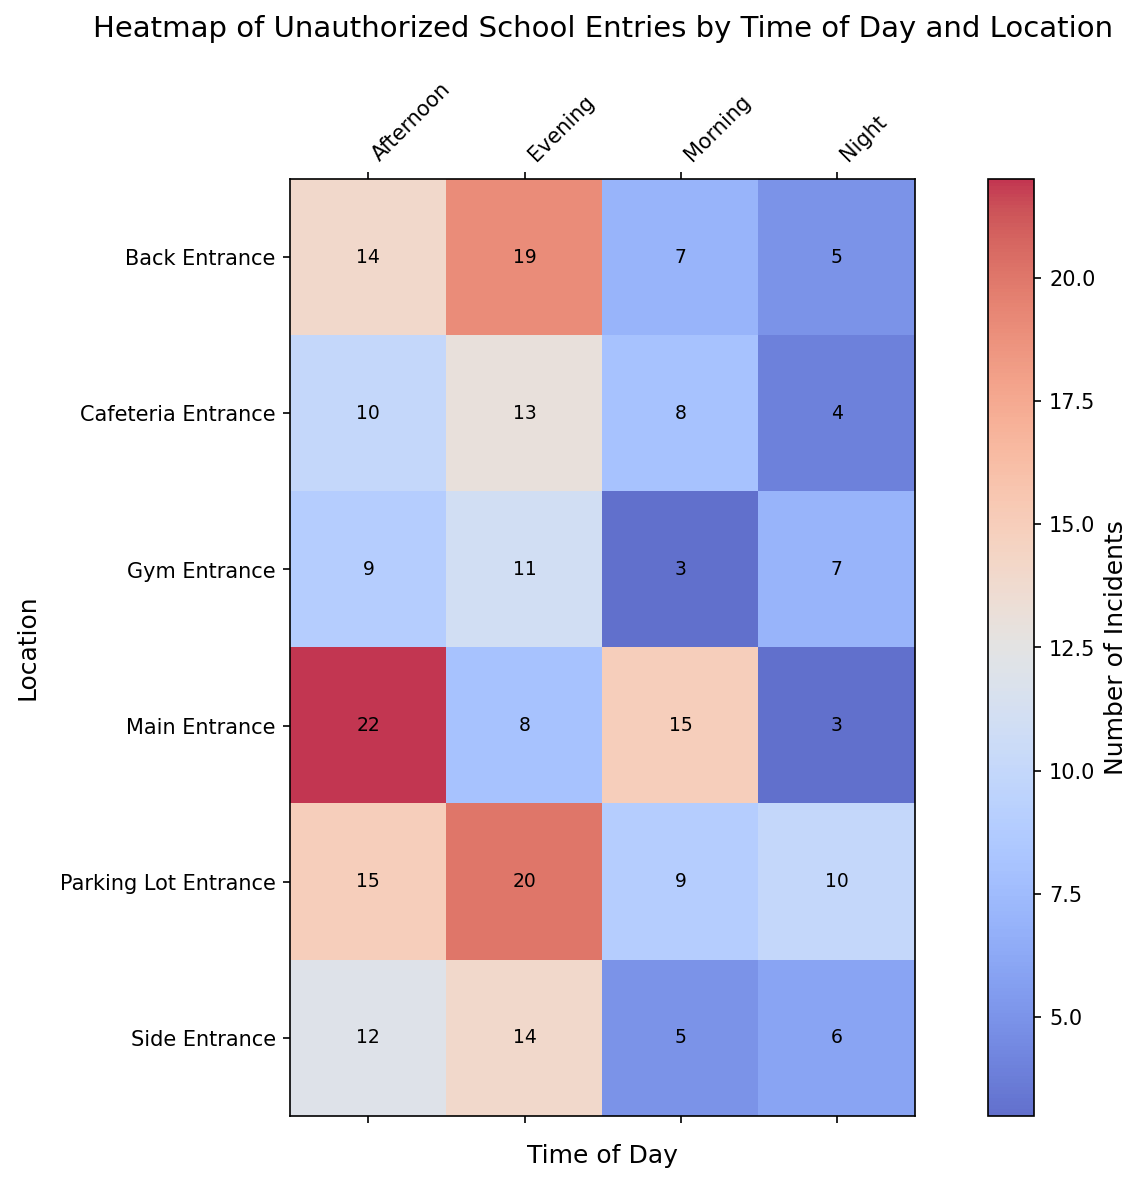Which location has the most incidents of unauthorized school entries during the evening? Look at the "Evening" column and identify the location with the highest number. The Parking Lot Entrance has 20 incidents, which is the highest.
Answer: Parking Lot Entrance Which time of day appears to have the fewest incidents overall across all locations? Sum the incidents for each time of day: Morning (47), Afternoon (82), Evening (85), Night (35). Night has the fewest.
Answer: Night How many more incidents occurred at the Main Entrance in the afternoon compared to the evening? Look at the Main Entrance row for Afternoon (22) and Evening (8). Subtract Evening from Afternoon: 22 - 8 = 14
Answer: 14 Which entrance has the highest incidents during the night, and how many incidents are there? Look at the "Night" column and find the highest number, which is at the Parking Lot Entrance with 10 incidents.
Answer: Parking Lot Entrance, 10 What is the average number of incidents at the Back Entrance across all times of the day? Calculate the average: (7 + 14 + 19 + 5) / 4 = 45 / 4 = 11.25
Answer: 11.25 How does the total number of incidents at the Side Entrance compare to the Gym Entrance? Sum the incidents for both: Side Entrance (5 + 12 + 14 + 6 = 37), Gym Entrance (3 + 9 + 11 + 7 = 30). Side Entrance has 7 more incidents.
Answer: Side Entrance has 7 more incidents Which time of day shows the most significant variation in incidents across different locations? Compare the ranges (max - min) for each time of day: Morning (15 - 3 = 12), Afternoon (22 - 9 = 13), Evening (20 - 8 = 12), Night (10 - 3 = 7). Afternoon shows the most variation.
Answer: Afternoon What percentage of the total incidents at the Cafeteria Entrance occurs in the evening? Calculate the percentage: (Evening at Cafeteria Entrance / Total at Cafeteria Entrance) * 100 = (13 / (8 + 10 + 13 + 4)) * 100 = (13 / 35) * 100 ≈ 37.14%
Answer: 37.14% If we exclude the Parking Lot Entrance, which location has the second highest number of incidents in the evening? Excluding the Parking Lot Entrance (which has 20), the Back Entrance has the next highest number with 19 incidents in the evening.
Answer: Back Entrance 